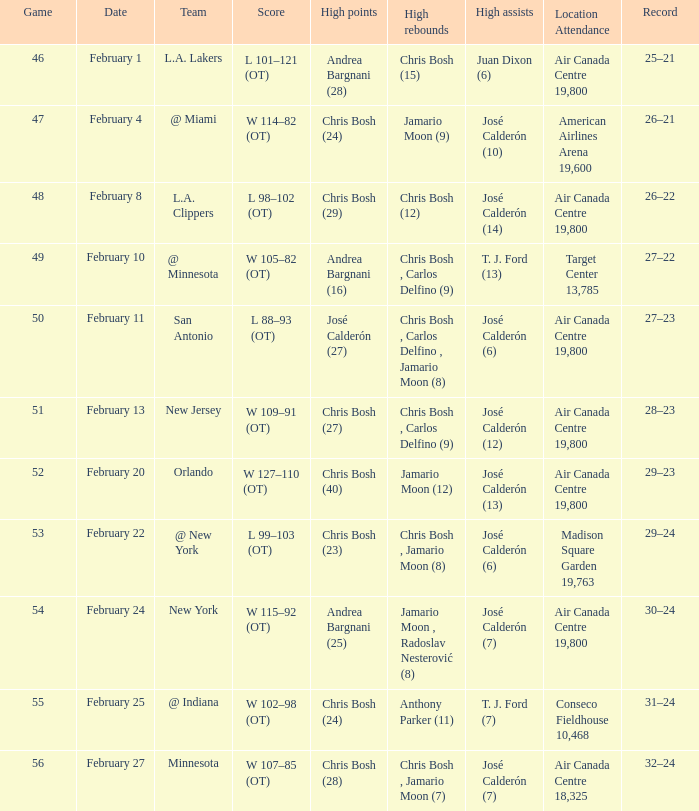What is the date of Game 50? February 11. 